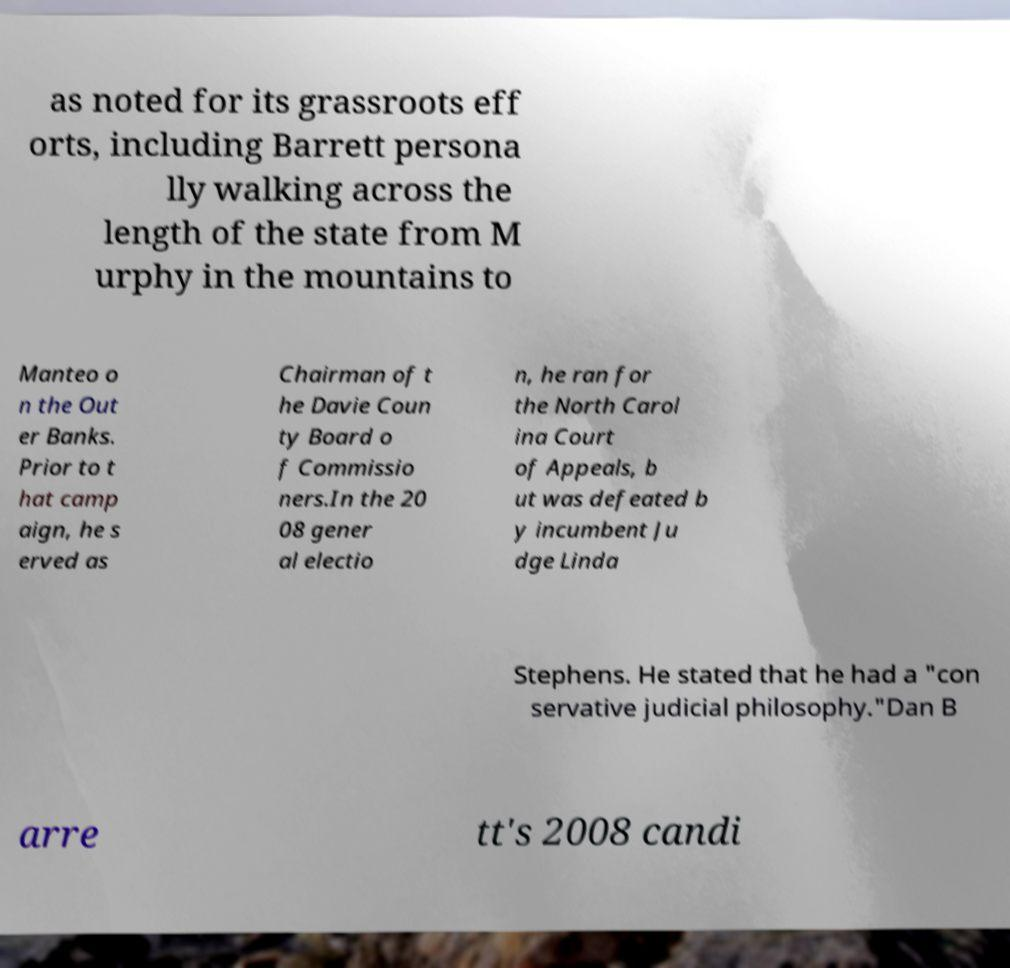Can you read and provide the text displayed in the image?This photo seems to have some interesting text. Can you extract and type it out for me? as noted for its grassroots eff orts, including Barrett persona lly walking across the length of the state from M urphy in the mountains to Manteo o n the Out er Banks. Prior to t hat camp aign, he s erved as Chairman of t he Davie Coun ty Board o f Commissio ners.In the 20 08 gener al electio n, he ran for the North Carol ina Court of Appeals, b ut was defeated b y incumbent Ju dge Linda Stephens. He stated that he had a "con servative judicial philosophy."Dan B arre tt's 2008 candi 